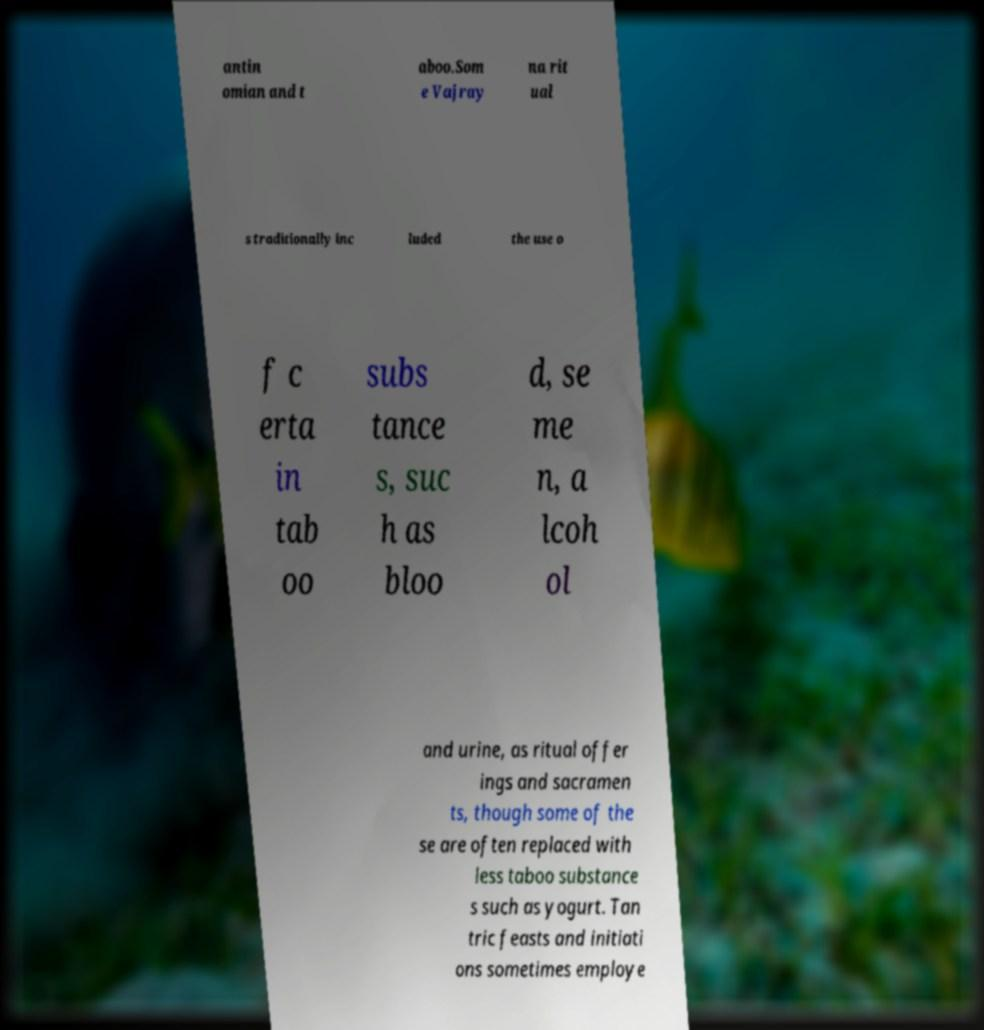There's text embedded in this image that I need extracted. Can you transcribe it verbatim? antin omian and t aboo.Som e Vajray na rit ual s traditionally inc luded the use o f c erta in tab oo subs tance s, suc h as bloo d, se me n, a lcoh ol and urine, as ritual offer ings and sacramen ts, though some of the se are often replaced with less taboo substance s such as yogurt. Tan tric feasts and initiati ons sometimes employe 